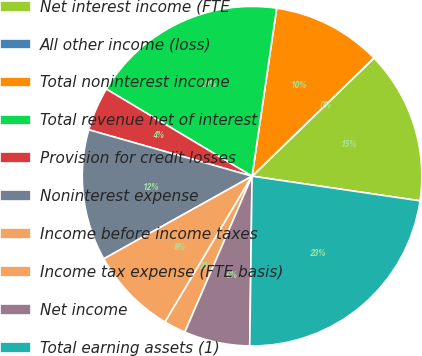Convert chart. <chart><loc_0><loc_0><loc_500><loc_500><pie_chart><fcel>Net interest income (FTE<fcel>All other income (loss)<fcel>Total noninterest income<fcel>Total revenue net of interest<fcel>Provision for credit losses<fcel>Noninterest expense<fcel>Income before income taxes<fcel>Income tax expense (FTE basis)<fcel>Net income<fcel>Total earning assets (1)<nl><fcel>14.58%<fcel>0.01%<fcel>10.42%<fcel>18.74%<fcel>4.17%<fcel>12.5%<fcel>8.34%<fcel>2.09%<fcel>6.26%<fcel>22.9%<nl></chart> 